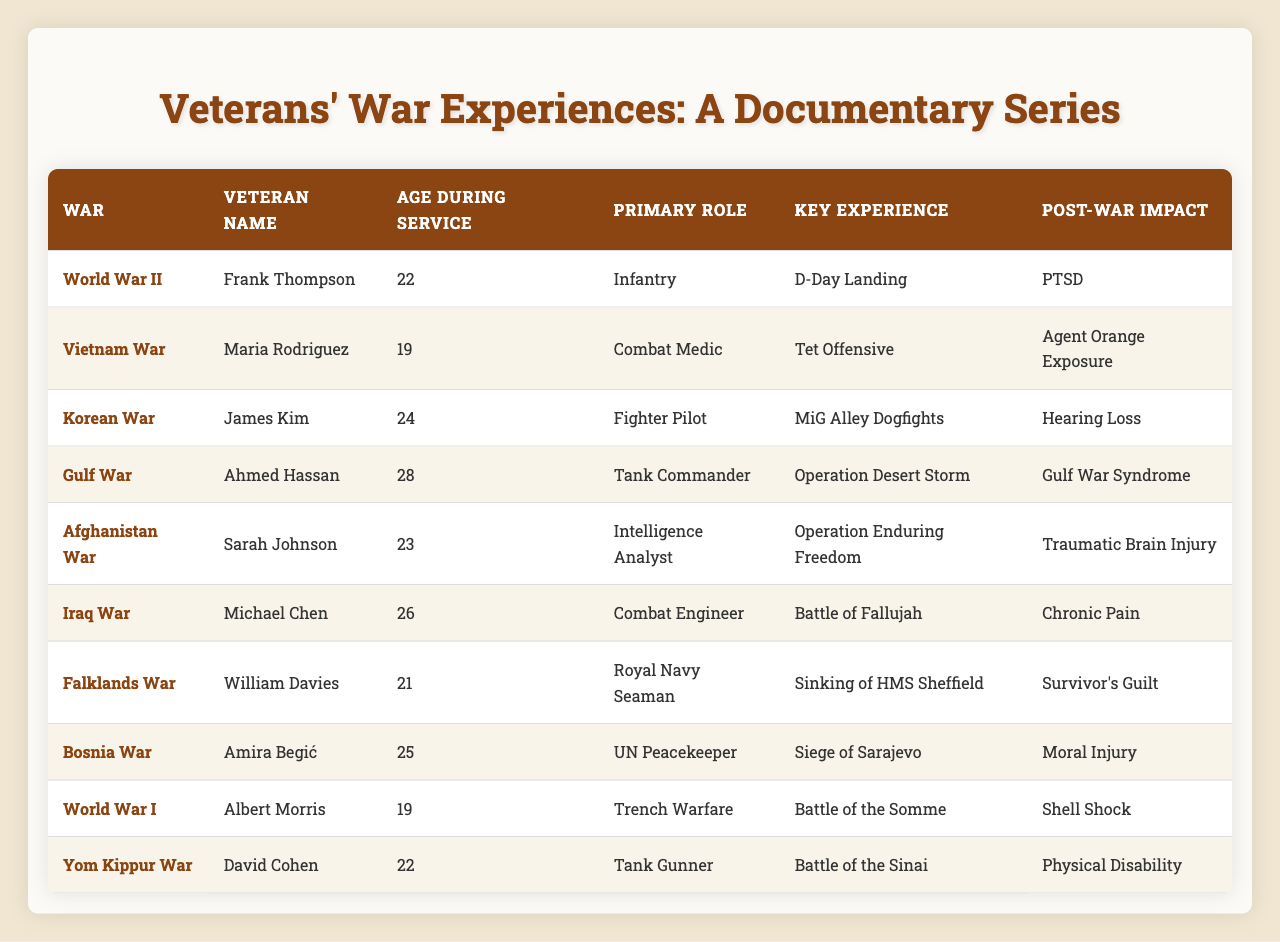What was the key experience of Frank Thompson during World War II? According to the table, Frank Thompson’s key experience during World War II was the D-Day Landing.
Answer: D-Day Landing How old was Maria Rodriguez when she served in the Vietnam War? The table states that Maria Rodriguez was 19 years old during her service in the Vietnam War.
Answer: 19 What post-war impact did James Kim experience after the Korean War? James Kim experienced hearing loss as a post-war impact after the Korean War, as indicated in the table.
Answer: Hearing Loss How many veterans were 22 years old during their service? The table lists two veterans who were 22 years old during their service: Frank Thompson and David Cohen. Thus, the total is 2.
Answer: 2 Which war had a veteran that reported PTSD as a post-war impact? The table shows that Frank Thompson, who served in World War II, reported PTSD as a post-war impact.
Answer: World War II Did any veterans report survivor's guilt as a post-war impact? Yes, the table states that William Davies, who served in the Falklands War, reported survivor's guilt as a post-war impact.
Answer: Yes What is the primary role of Michael Chen in the Iraq War? According to the table, Michael Chen's primary role in the Iraq War was as a Combat Engineer.
Answer: Combat Engineer Which war had the oldest veteran based on the ages recorded during service? The ages listed for veterans in the table show that the Gulf War veteran, Ahmed Hassan, was 28 years old, making him the oldest during service.
Answer: Gulf War What was the sum of the ages during service for all listed veterans? The ages during service for the veterans are 22, 19, 24, 28, 23, 26, 21, 25, 19, and 22, which total to  22 + 19 + 24 + 28 + 23 + 26 + 21 + 25 + 19 + 22 =  239.
Answer: 239 How many veterans served in conflicts that were not part of the United States' major wars? By examining the table, only William Davies in the Falklands War and Amira Begić in the Bosnia War can be classified in this category. Thus, the answer is 2.
Answer: 2 